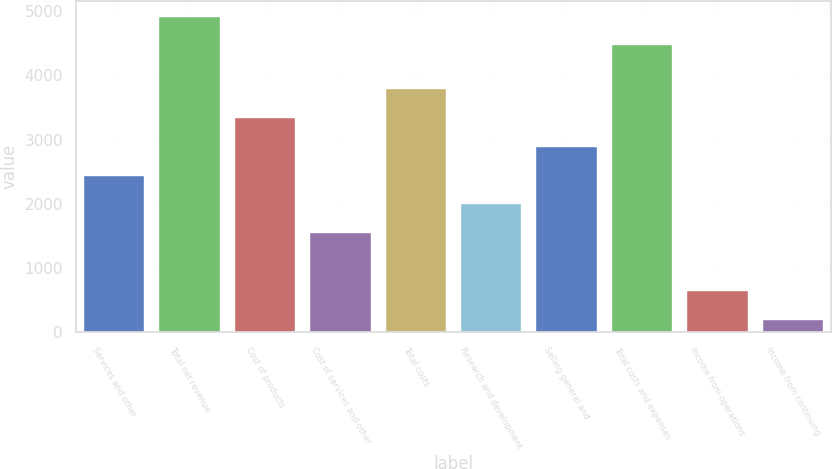Convert chart to OTSL. <chart><loc_0><loc_0><loc_500><loc_500><bar_chart><fcel>Services and other<fcel>Total net revenue<fcel>Cost of products<fcel>Cost of services and other<fcel>Total costs<fcel>Research and development<fcel>Selling general and<fcel>Total costs and expenses<fcel>Income from operations<fcel>Income from continuing<nl><fcel>2438<fcel>4918.4<fcel>3336.8<fcel>1539.2<fcel>3786.2<fcel>1988.6<fcel>2887.4<fcel>4469<fcel>640.4<fcel>191<nl></chart> 